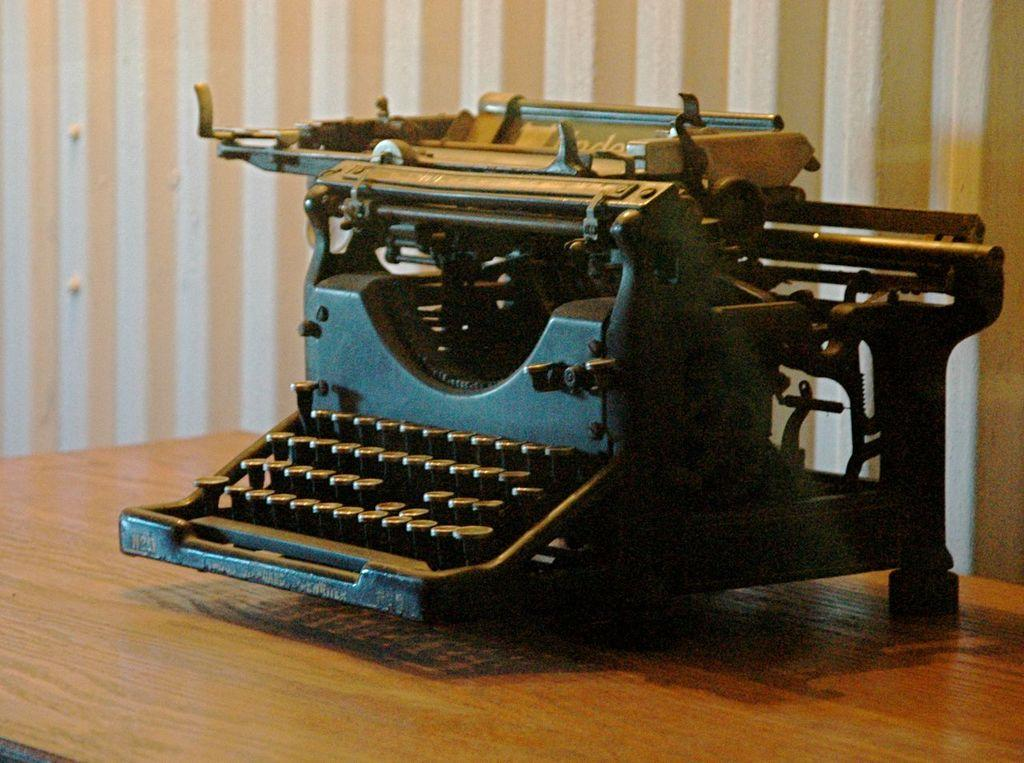What is located at the bottom of the image? There is a table at the bottom of the image. What object is placed on the table? A typing machine is placed on the table. What can be seen in the background of the image? There is a wall in the background of the image. How many caps can be seen on the trains in the image? There are no trains or caps present in the image; it features a table with a typing machine and a wall in the background. 